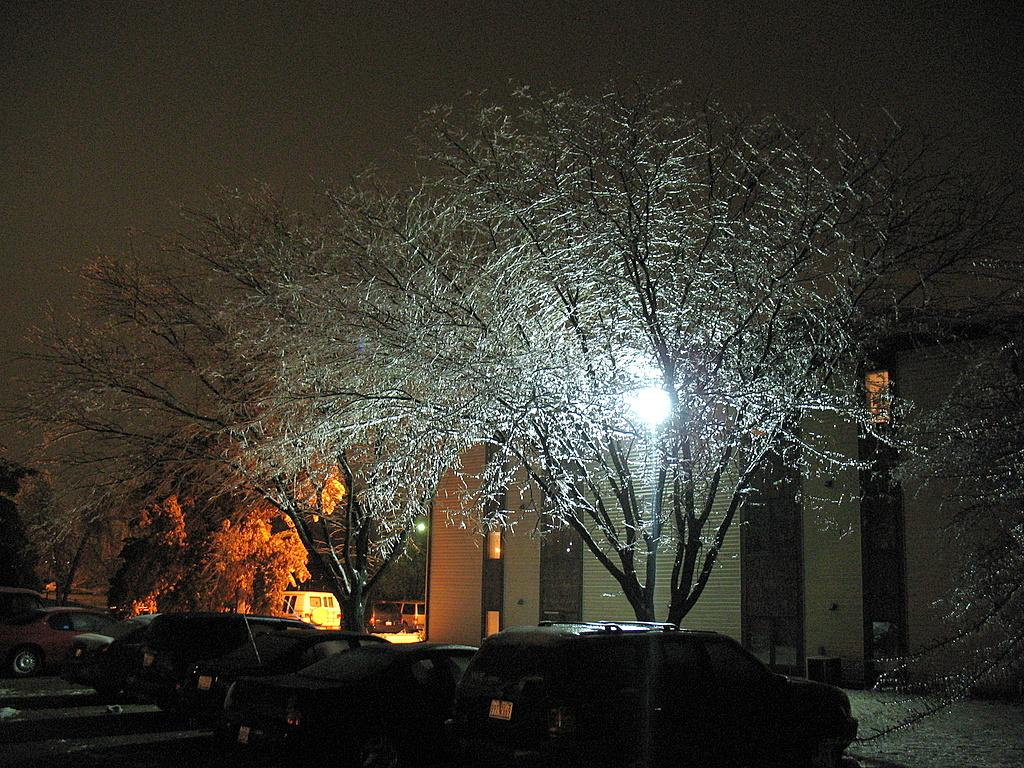What type of vehicles can be seen in the image? There are cars parked in the image. Can you describe the tree in the image? There is a dry tree with a spotlight in the image. What can be seen in the background of the image? There is a small white-colored building in the background of the image. What type of legal advice is the lawyer giving in the image? There is no lawyer present in the image, so it is not possible to determine what legal advice might be given. 